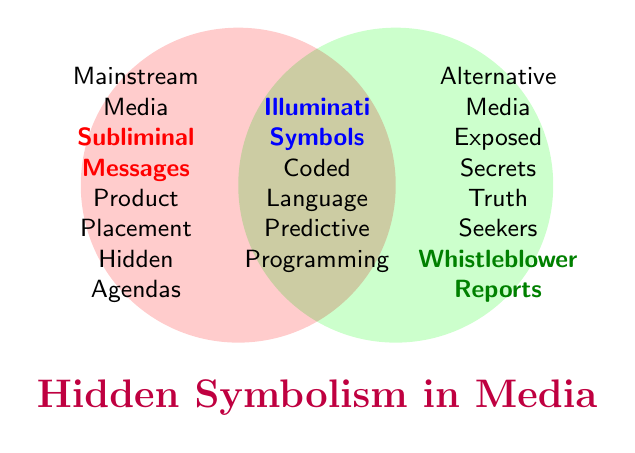How many elements are exclusive to Mainstream Media? The elements exclusive to Mainstream Media are listed in the circle for Mainstream Media. Counting these elements gives us three: Subliminal Messages, Product Placement, and Hidden Agendas.
Answer: Three Which elements appear in both Mainstream Media and Alternative Media? The elements shared by both Mainstream Media and Alternative Media are listed in the intersecting area between the two circles. These elements are: Illuminati Symbols, Coded Language, and Predictive Programming.
Answer: Three What is the title of the figure? The title of the figure is mentioned at the bottom part of the Venn diagram.
Answer: Hidden Symbolism in Media How many elements are solely identified with Alternative Media? The elements exclusive to Alternative Media are listed in the circle for Alternative Media. Counting these elements gives us three: Exposed Secrets, Truth Seekers, and Whistleblower Reports.
Answer: Three Does Alternative Media contain any elements that are also in Mainstream Media? The intersection of the two circles shows elements that are in both Mainstream Media and Alternative Media. Elements like Illuminati Symbols, Coded Language, and Predictive Programming appear in both.
Answer: Yes Which category includes Subliminal Messages? Subliminal Messages is located under the Mainstream Media category. It is listed right inside the circle for Mainstream Media.
Answer: Mainstream Media Compare the number of unique elements in Mainstream Media and Alternative Media. Which category has more unique elements? Counting the unique elements in each category, Mainstream Media has three (Subliminal Messages, Product Placement, and Hidden Agendas), and Alternative Media also has three (Exposed Secrets, Truth Seekers, and Whistleblower Reports). Both categories have the same number of unique elements.
Answer: Equal List all elements that appear in the Venn diagram. Combining the elements from Mainstream Media, Alternative Media, and both categories, the complete list includes: Subliminal Messages, Product Placement, Hidden Agendas, Exposed Secrets, Truth Seekers, Whistleblower Reports, Illuminati Symbols, Coded Language, and Predictive Programming.
Answer: Nine 